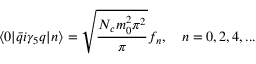Convert formula to latex. <formula><loc_0><loc_0><loc_500><loc_500>\langle 0 | \bar { q } i \gamma _ { 5 } q | n \rangle = \sqrt { \frac { N _ { c } m _ { 0 } ^ { 2 } \pi ^ { 2 } } { \pi } } f _ { n } , n = 0 , 2 , 4 , \dots</formula> 